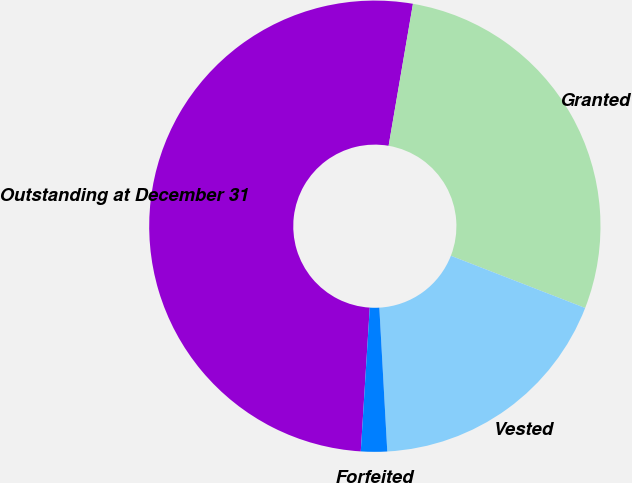Convert chart. <chart><loc_0><loc_0><loc_500><loc_500><pie_chart><fcel>Outstanding at December 31<fcel>Granted<fcel>Vested<fcel>Forfeited<nl><fcel>51.71%<fcel>28.2%<fcel>18.22%<fcel>1.87%<nl></chart> 